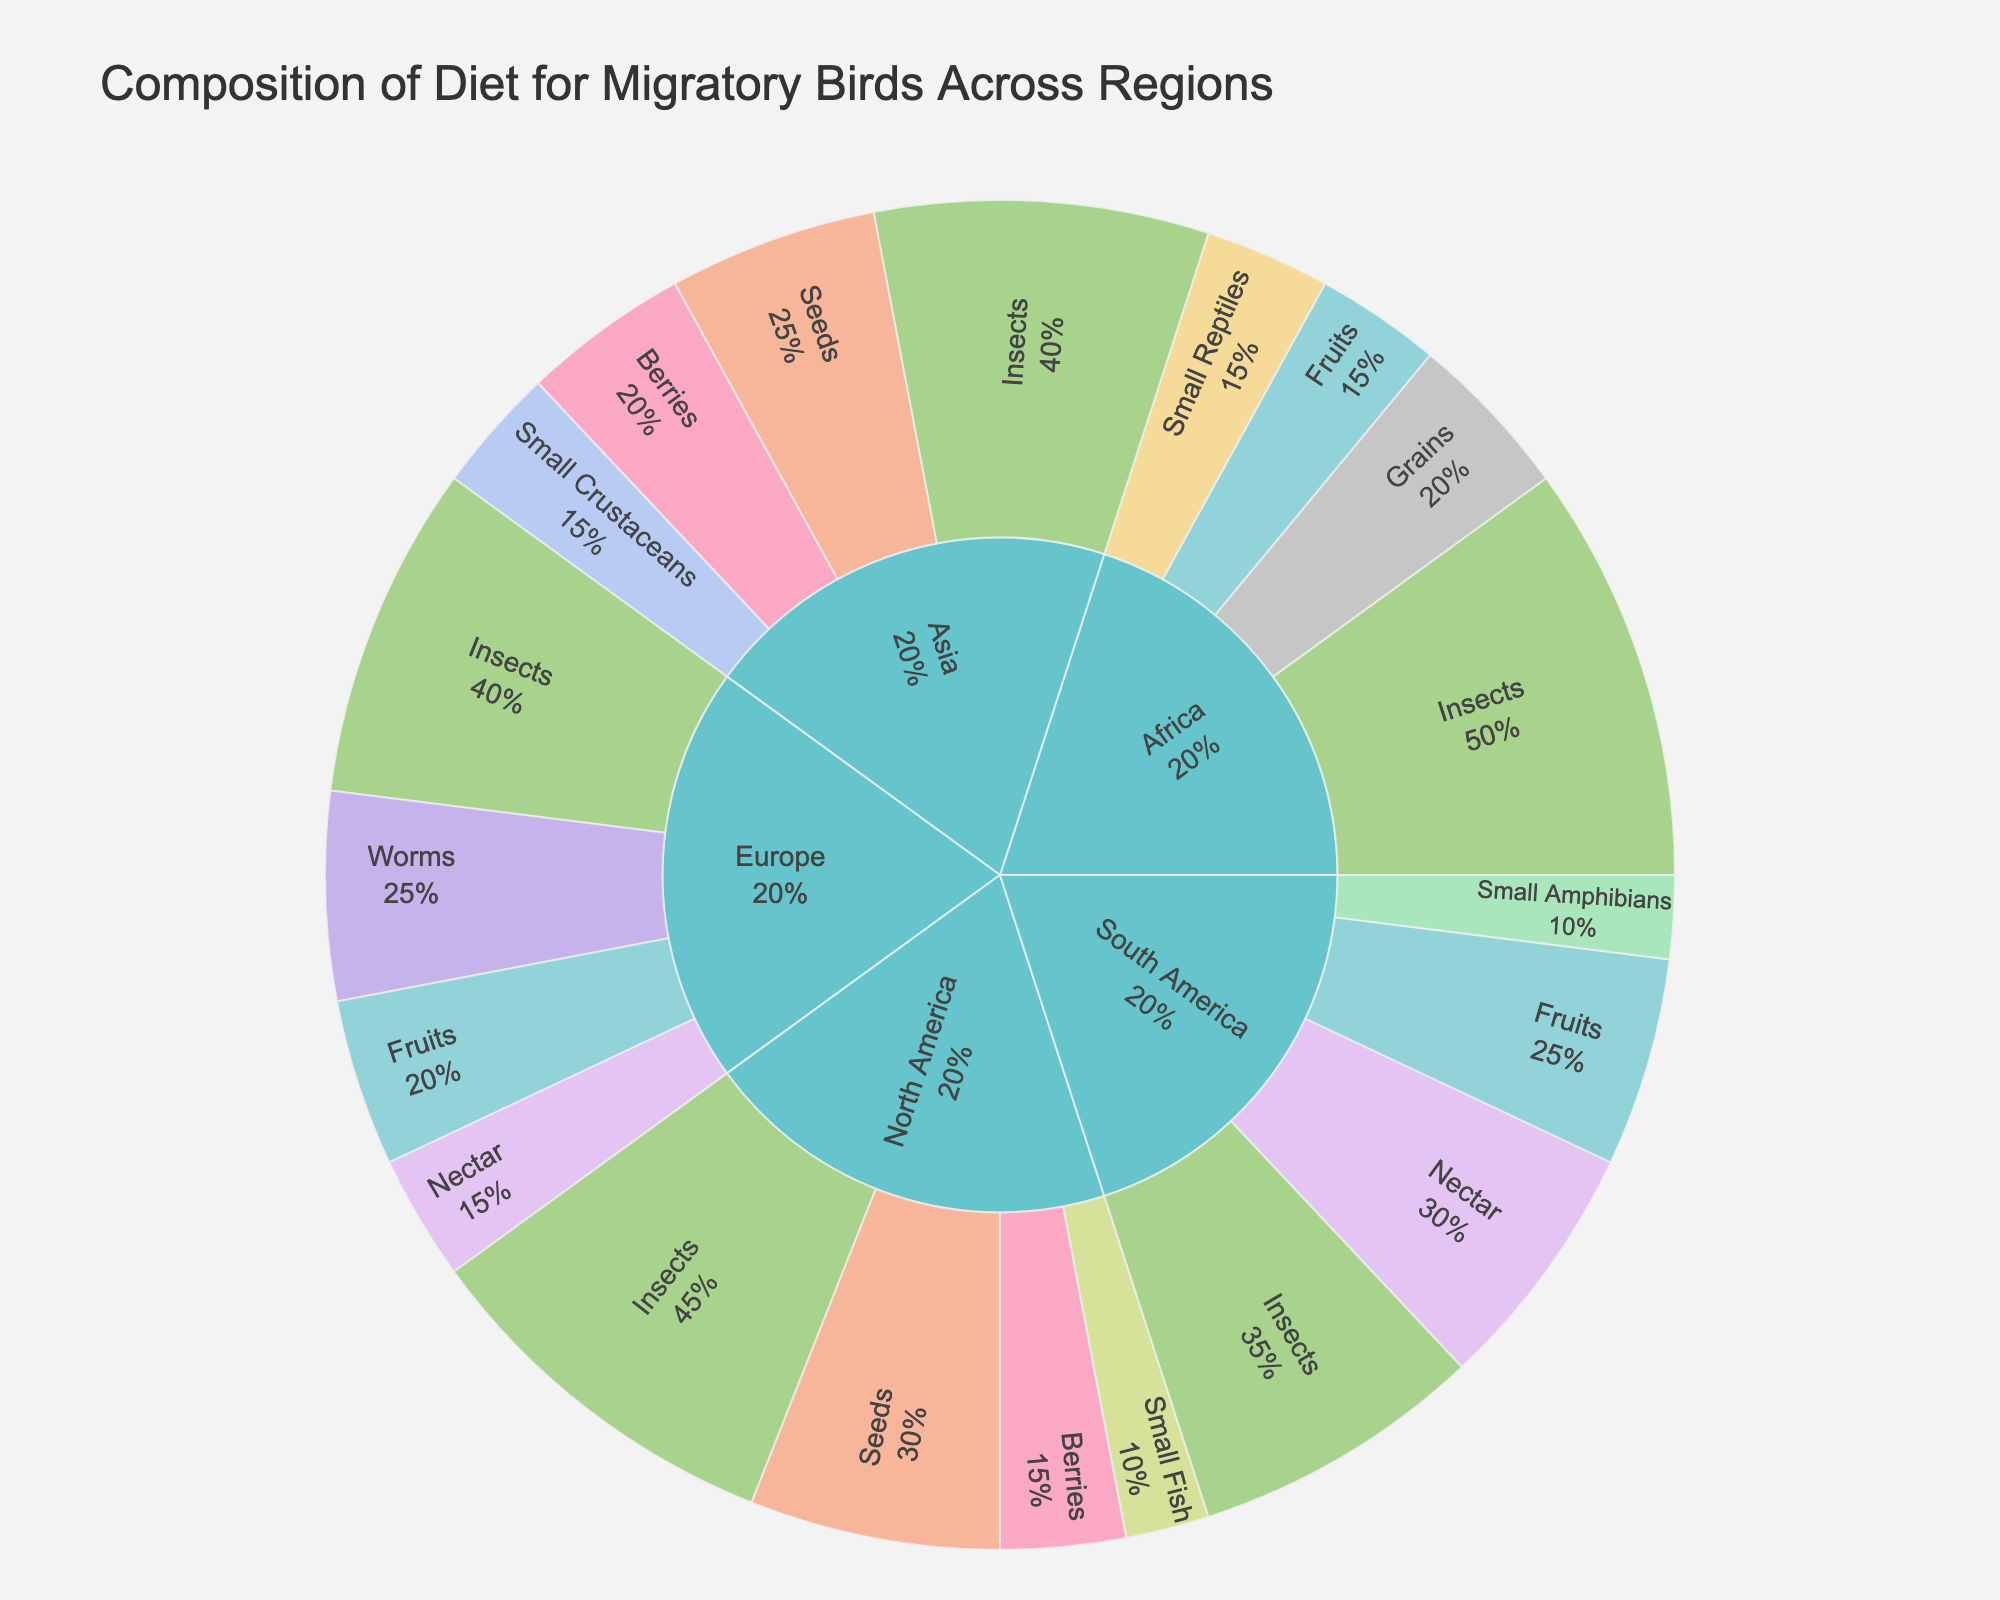Which region has the highest percentage of insects in the diet of migratory birds? North America has 45%, Europe has 40%, Africa has 50%, and South America has 35% of insects. Africa has the highest percentage of insects in the diet of migratory birds.
Answer: Africa Which region has the lowest percentage of fruits in the diet of migratory birds? North America has 0%, Europe has 20%, Africa has 15%, and South America has 25% of fruits. North America has the lowest percentage of fruits in the diet of migratory birds.
Answer: North America Which two food types together make up the highest percentage in South America? In South America, insects make up 35% and nectar makes up 30%. Together, they account for 35% + 30% = 65%, which is the highest combined percentage.
Answer: Insects and Nectar Which region's birds consume the highest combined percentage of seeds and grains? In North America, seeds are 30% and no grains are listed. In Africa, grains are 20%, but no seeds are listed. In Asia, seeds are 25% and no grains are listed. Summing for each region, North America is 30% + 0% = 30%, Africa is 0% + 20% = 20%, and Asia is 25% + 0% = 25%. North America has the highest combined percentage for seeds and grains.
Answer: North America How does the percentage of small fish in North America compare to the percentage of small crustaceans in Asia? North America has 10% of small fish, and Asia has 15% of small crustaceans. Asia's percentage of small crustaceans is higher than North America's percentage of small fish.
Answer: Asia's is higher Which food type is equally distributed in two different regions, and what are those regions? The 'Fruits' category is equally distributed at 15% in both Africa and Europe.
Answer: Africa and Europe What is the total percentage of diet consisting of animal matter (insects, fish, worms, reptiles, amphibians, crustaceans) in Europe? Europe has insects (40%), worms (25%). Summing these percentages gives 40% + 25% = 65%.
Answer: 65% If you combine the percentage of berries and fruits, which region has the highest combined percentage? North America has berries (15%) + fruits (0%) = 15%. Europe has fruits (20%) + berries (0%) = 20%. Africa has fruits (15%) and no berries. South America has fruits (25%) and no berries. Europe has the highest combined percentage (20%) of berries and fruits.
Answer: Europe In which region do migratory birds' diets comprise more animal matter than plant matter? North America has 45% (insects) + 10% (small fish) = 55% animal matter and 30% (seeds) + 15% (berries) = 45% plant matter. Europe has 40% (insects) + 25% (worms) = 65% animal matter and 20% (fruits) + 15% (nectar) = 35% plant matter. Africa has 50% (insects) + 15% (small reptiles) = 65% animal matter and 20% (grains) + 15% (fruits) = 35% plant matter. South America has 35% (insects) + 10% (small amphibians) = 45% animal matter and 30% (nectar) + 25% (fruits) = 55% plant matter. Thus, Europe and Africa have more animal matter in their diets.
Answer: Europe and Africa 